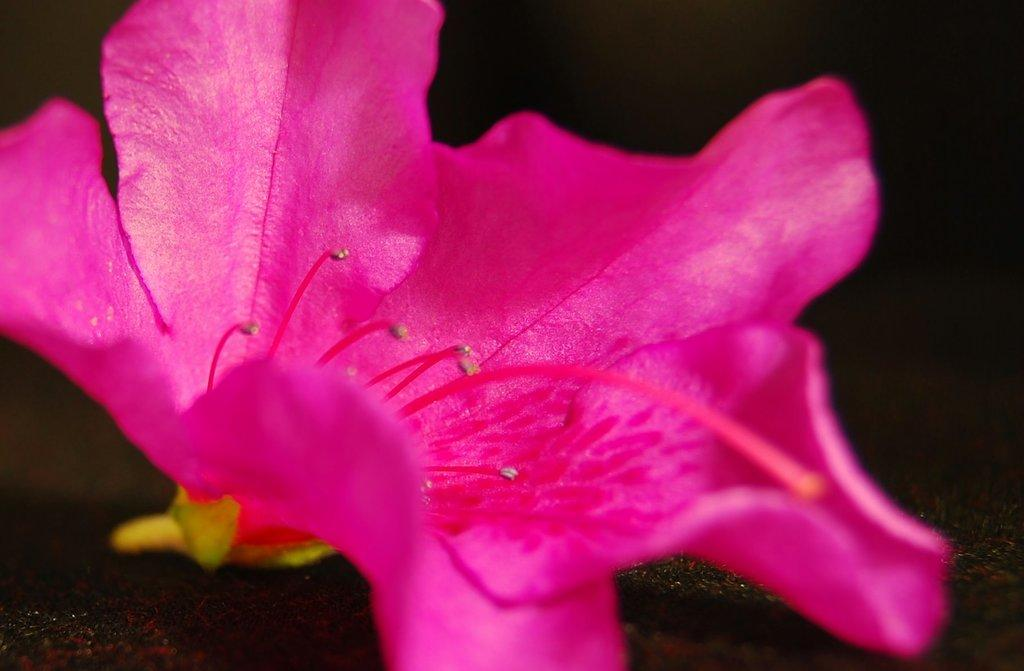What is the main subject of the image? There is a flower in the image. Can you describe the colors of the flower? The flower has pink and yellow colors. What is the flower resting on in the image? The flower is on a black surface. What color is the background of the image? The background of the image is black. Can you tell me how many breaths the ant takes in the image? There is no ant present in the image, so it is not possible to determine the number of breaths it might take. 